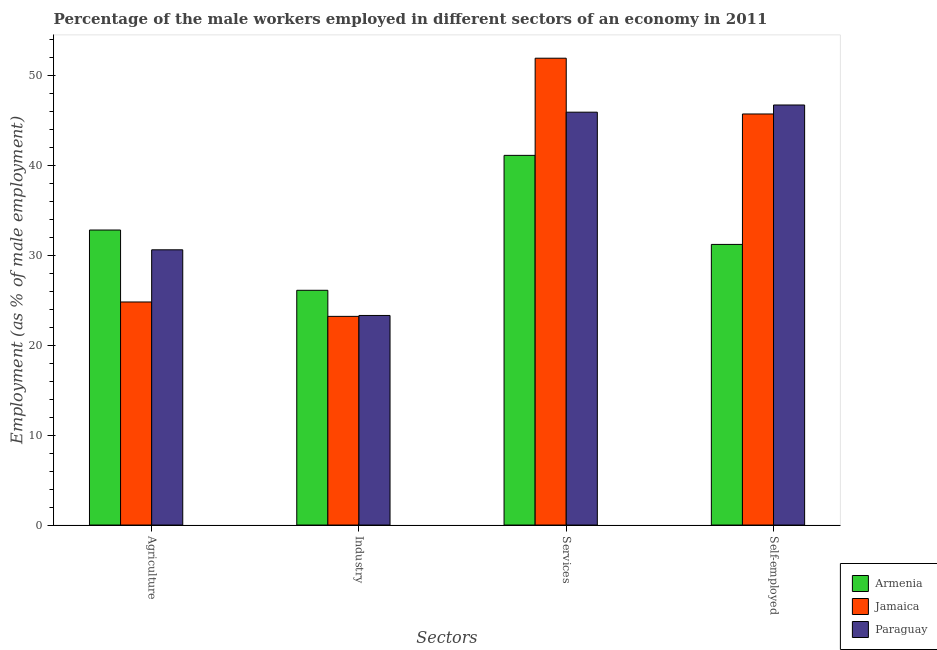How many groups of bars are there?
Offer a terse response. 4. Are the number of bars per tick equal to the number of legend labels?
Your response must be concise. Yes. How many bars are there on the 3rd tick from the left?
Offer a terse response. 3. How many bars are there on the 4th tick from the right?
Your response must be concise. 3. What is the label of the 2nd group of bars from the left?
Your answer should be compact. Industry. What is the percentage of male workers in industry in Jamaica?
Provide a short and direct response. 23.2. Across all countries, what is the maximum percentage of male workers in agriculture?
Provide a succinct answer. 32.8. Across all countries, what is the minimum percentage of male workers in industry?
Your response must be concise. 23.2. In which country was the percentage of male workers in services maximum?
Your answer should be very brief. Jamaica. In which country was the percentage of self employed male workers minimum?
Ensure brevity in your answer.  Armenia. What is the total percentage of male workers in services in the graph?
Give a very brief answer. 138.9. What is the difference between the percentage of male workers in industry in Paraguay and that in Jamaica?
Your answer should be very brief. 0.1. What is the difference between the percentage of self employed male workers in Paraguay and the percentage of male workers in industry in Jamaica?
Your answer should be compact. 23.5. What is the average percentage of male workers in agriculture per country?
Your response must be concise. 29.4. What is the difference between the percentage of male workers in industry and percentage of male workers in agriculture in Paraguay?
Provide a succinct answer. -7.3. In how many countries, is the percentage of male workers in services greater than 48 %?
Provide a succinct answer. 1. What is the ratio of the percentage of self employed male workers in Jamaica to that in Armenia?
Your answer should be compact. 1.46. What is the difference between the highest and the lowest percentage of male workers in industry?
Offer a terse response. 2.9. Is the sum of the percentage of male workers in agriculture in Paraguay and Jamaica greater than the maximum percentage of male workers in services across all countries?
Your answer should be compact. Yes. Is it the case that in every country, the sum of the percentage of male workers in services and percentage of self employed male workers is greater than the sum of percentage of male workers in agriculture and percentage of male workers in industry?
Your answer should be compact. Yes. What does the 1st bar from the left in Industry represents?
Your response must be concise. Armenia. What does the 2nd bar from the right in Services represents?
Offer a very short reply. Jamaica. Is it the case that in every country, the sum of the percentage of male workers in agriculture and percentage of male workers in industry is greater than the percentage of male workers in services?
Offer a terse response. No. Are all the bars in the graph horizontal?
Your answer should be very brief. No. How many countries are there in the graph?
Your answer should be compact. 3. What is the difference between two consecutive major ticks on the Y-axis?
Keep it short and to the point. 10. Does the graph contain any zero values?
Provide a short and direct response. No. Where does the legend appear in the graph?
Your response must be concise. Bottom right. How many legend labels are there?
Ensure brevity in your answer.  3. How are the legend labels stacked?
Provide a succinct answer. Vertical. What is the title of the graph?
Your response must be concise. Percentage of the male workers employed in different sectors of an economy in 2011. What is the label or title of the X-axis?
Give a very brief answer. Sectors. What is the label or title of the Y-axis?
Provide a succinct answer. Employment (as % of male employment). What is the Employment (as % of male employment) in Armenia in Agriculture?
Keep it short and to the point. 32.8. What is the Employment (as % of male employment) in Jamaica in Agriculture?
Provide a succinct answer. 24.8. What is the Employment (as % of male employment) in Paraguay in Agriculture?
Give a very brief answer. 30.6. What is the Employment (as % of male employment) of Armenia in Industry?
Ensure brevity in your answer.  26.1. What is the Employment (as % of male employment) in Jamaica in Industry?
Offer a very short reply. 23.2. What is the Employment (as % of male employment) of Paraguay in Industry?
Provide a short and direct response. 23.3. What is the Employment (as % of male employment) in Armenia in Services?
Give a very brief answer. 41.1. What is the Employment (as % of male employment) in Jamaica in Services?
Your response must be concise. 51.9. What is the Employment (as % of male employment) in Paraguay in Services?
Your answer should be very brief. 45.9. What is the Employment (as % of male employment) in Armenia in Self-employed?
Your response must be concise. 31.2. What is the Employment (as % of male employment) of Jamaica in Self-employed?
Your answer should be very brief. 45.7. What is the Employment (as % of male employment) of Paraguay in Self-employed?
Your answer should be very brief. 46.7. Across all Sectors, what is the maximum Employment (as % of male employment) in Armenia?
Keep it short and to the point. 41.1. Across all Sectors, what is the maximum Employment (as % of male employment) of Jamaica?
Your answer should be very brief. 51.9. Across all Sectors, what is the maximum Employment (as % of male employment) in Paraguay?
Provide a succinct answer. 46.7. Across all Sectors, what is the minimum Employment (as % of male employment) in Armenia?
Your answer should be very brief. 26.1. Across all Sectors, what is the minimum Employment (as % of male employment) in Jamaica?
Give a very brief answer. 23.2. Across all Sectors, what is the minimum Employment (as % of male employment) in Paraguay?
Keep it short and to the point. 23.3. What is the total Employment (as % of male employment) of Armenia in the graph?
Offer a very short reply. 131.2. What is the total Employment (as % of male employment) in Jamaica in the graph?
Give a very brief answer. 145.6. What is the total Employment (as % of male employment) in Paraguay in the graph?
Provide a short and direct response. 146.5. What is the difference between the Employment (as % of male employment) of Paraguay in Agriculture and that in Industry?
Offer a very short reply. 7.3. What is the difference between the Employment (as % of male employment) in Jamaica in Agriculture and that in Services?
Ensure brevity in your answer.  -27.1. What is the difference between the Employment (as % of male employment) of Paraguay in Agriculture and that in Services?
Your answer should be compact. -15.3. What is the difference between the Employment (as % of male employment) of Jamaica in Agriculture and that in Self-employed?
Offer a terse response. -20.9. What is the difference between the Employment (as % of male employment) of Paraguay in Agriculture and that in Self-employed?
Provide a succinct answer. -16.1. What is the difference between the Employment (as % of male employment) of Jamaica in Industry and that in Services?
Give a very brief answer. -28.7. What is the difference between the Employment (as % of male employment) of Paraguay in Industry and that in Services?
Provide a succinct answer. -22.6. What is the difference between the Employment (as % of male employment) in Armenia in Industry and that in Self-employed?
Offer a terse response. -5.1. What is the difference between the Employment (as % of male employment) in Jamaica in Industry and that in Self-employed?
Ensure brevity in your answer.  -22.5. What is the difference between the Employment (as % of male employment) of Paraguay in Industry and that in Self-employed?
Give a very brief answer. -23.4. What is the difference between the Employment (as % of male employment) in Paraguay in Services and that in Self-employed?
Ensure brevity in your answer.  -0.8. What is the difference between the Employment (as % of male employment) of Armenia in Agriculture and the Employment (as % of male employment) of Jamaica in Industry?
Your response must be concise. 9.6. What is the difference between the Employment (as % of male employment) of Armenia in Agriculture and the Employment (as % of male employment) of Paraguay in Industry?
Your answer should be very brief. 9.5. What is the difference between the Employment (as % of male employment) of Jamaica in Agriculture and the Employment (as % of male employment) of Paraguay in Industry?
Your response must be concise. 1.5. What is the difference between the Employment (as % of male employment) of Armenia in Agriculture and the Employment (as % of male employment) of Jamaica in Services?
Offer a terse response. -19.1. What is the difference between the Employment (as % of male employment) of Armenia in Agriculture and the Employment (as % of male employment) of Paraguay in Services?
Offer a terse response. -13.1. What is the difference between the Employment (as % of male employment) in Jamaica in Agriculture and the Employment (as % of male employment) in Paraguay in Services?
Offer a very short reply. -21.1. What is the difference between the Employment (as % of male employment) in Armenia in Agriculture and the Employment (as % of male employment) in Jamaica in Self-employed?
Provide a short and direct response. -12.9. What is the difference between the Employment (as % of male employment) in Jamaica in Agriculture and the Employment (as % of male employment) in Paraguay in Self-employed?
Make the answer very short. -21.9. What is the difference between the Employment (as % of male employment) of Armenia in Industry and the Employment (as % of male employment) of Jamaica in Services?
Your answer should be very brief. -25.8. What is the difference between the Employment (as % of male employment) in Armenia in Industry and the Employment (as % of male employment) in Paraguay in Services?
Offer a terse response. -19.8. What is the difference between the Employment (as % of male employment) of Jamaica in Industry and the Employment (as % of male employment) of Paraguay in Services?
Offer a terse response. -22.7. What is the difference between the Employment (as % of male employment) in Armenia in Industry and the Employment (as % of male employment) in Jamaica in Self-employed?
Provide a short and direct response. -19.6. What is the difference between the Employment (as % of male employment) in Armenia in Industry and the Employment (as % of male employment) in Paraguay in Self-employed?
Your answer should be very brief. -20.6. What is the difference between the Employment (as % of male employment) in Jamaica in Industry and the Employment (as % of male employment) in Paraguay in Self-employed?
Offer a very short reply. -23.5. What is the difference between the Employment (as % of male employment) of Armenia in Services and the Employment (as % of male employment) of Paraguay in Self-employed?
Ensure brevity in your answer.  -5.6. What is the difference between the Employment (as % of male employment) in Jamaica in Services and the Employment (as % of male employment) in Paraguay in Self-employed?
Provide a succinct answer. 5.2. What is the average Employment (as % of male employment) of Armenia per Sectors?
Your response must be concise. 32.8. What is the average Employment (as % of male employment) of Jamaica per Sectors?
Give a very brief answer. 36.4. What is the average Employment (as % of male employment) in Paraguay per Sectors?
Keep it short and to the point. 36.62. What is the difference between the Employment (as % of male employment) in Armenia and Employment (as % of male employment) in Paraguay in Services?
Your answer should be compact. -4.8. What is the difference between the Employment (as % of male employment) in Armenia and Employment (as % of male employment) in Jamaica in Self-employed?
Your response must be concise. -14.5. What is the difference between the Employment (as % of male employment) in Armenia and Employment (as % of male employment) in Paraguay in Self-employed?
Give a very brief answer. -15.5. What is the ratio of the Employment (as % of male employment) in Armenia in Agriculture to that in Industry?
Your response must be concise. 1.26. What is the ratio of the Employment (as % of male employment) of Jamaica in Agriculture to that in Industry?
Offer a terse response. 1.07. What is the ratio of the Employment (as % of male employment) in Paraguay in Agriculture to that in Industry?
Ensure brevity in your answer.  1.31. What is the ratio of the Employment (as % of male employment) of Armenia in Agriculture to that in Services?
Your answer should be compact. 0.8. What is the ratio of the Employment (as % of male employment) in Jamaica in Agriculture to that in Services?
Your answer should be very brief. 0.48. What is the ratio of the Employment (as % of male employment) of Armenia in Agriculture to that in Self-employed?
Provide a short and direct response. 1.05. What is the ratio of the Employment (as % of male employment) of Jamaica in Agriculture to that in Self-employed?
Your response must be concise. 0.54. What is the ratio of the Employment (as % of male employment) in Paraguay in Agriculture to that in Self-employed?
Your answer should be compact. 0.66. What is the ratio of the Employment (as % of male employment) of Armenia in Industry to that in Services?
Make the answer very short. 0.64. What is the ratio of the Employment (as % of male employment) in Jamaica in Industry to that in Services?
Provide a succinct answer. 0.45. What is the ratio of the Employment (as % of male employment) of Paraguay in Industry to that in Services?
Your response must be concise. 0.51. What is the ratio of the Employment (as % of male employment) of Armenia in Industry to that in Self-employed?
Offer a very short reply. 0.84. What is the ratio of the Employment (as % of male employment) of Jamaica in Industry to that in Self-employed?
Give a very brief answer. 0.51. What is the ratio of the Employment (as % of male employment) in Paraguay in Industry to that in Self-employed?
Make the answer very short. 0.5. What is the ratio of the Employment (as % of male employment) in Armenia in Services to that in Self-employed?
Provide a short and direct response. 1.32. What is the ratio of the Employment (as % of male employment) in Jamaica in Services to that in Self-employed?
Your response must be concise. 1.14. What is the ratio of the Employment (as % of male employment) in Paraguay in Services to that in Self-employed?
Offer a terse response. 0.98. What is the difference between the highest and the second highest Employment (as % of male employment) in Armenia?
Give a very brief answer. 8.3. What is the difference between the highest and the second highest Employment (as % of male employment) of Paraguay?
Offer a terse response. 0.8. What is the difference between the highest and the lowest Employment (as % of male employment) of Jamaica?
Your answer should be very brief. 28.7. What is the difference between the highest and the lowest Employment (as % of male employment) of Paraguay?
Offer a very short reply. 23.4. 